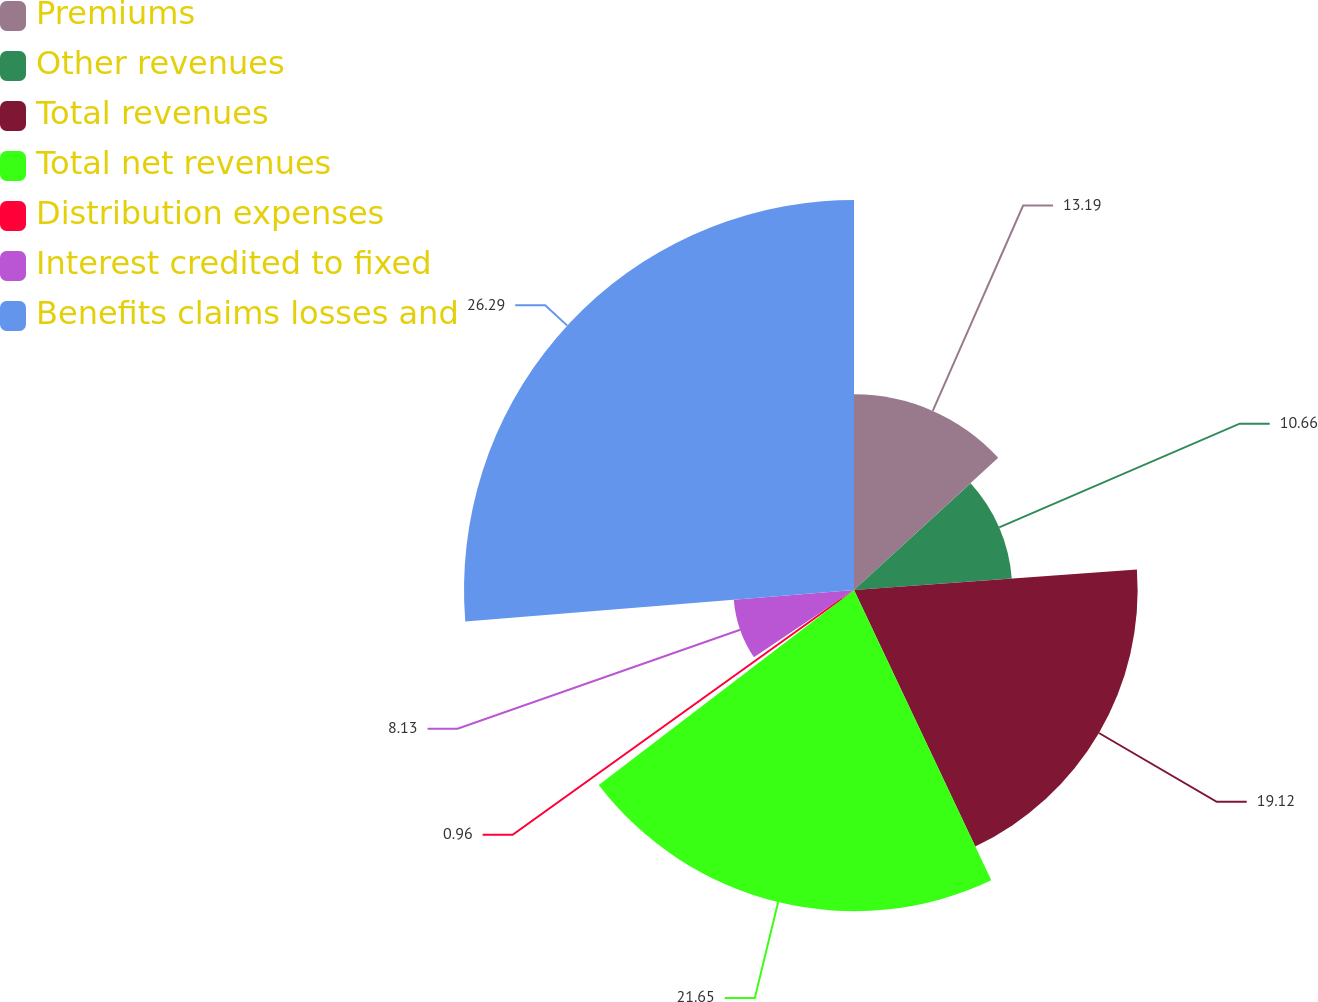<chart> <loc_0><loc_0><loc_500><loc_500><pie_chart><fcel>Premiums<fcel>Other revenues<fcel>Total revenues<fcel>Total net revenues<fcel>Distribution expenses<fcel>Interest credited to fixed<fcel>Benefits claims losses and<nl><fcel>13.19%<fcel>10.66%<fcel>19.12%<fcel>21.65%<fcel>0.96%<fcel>8.13%<fcel>26.29%<nl></chart> 